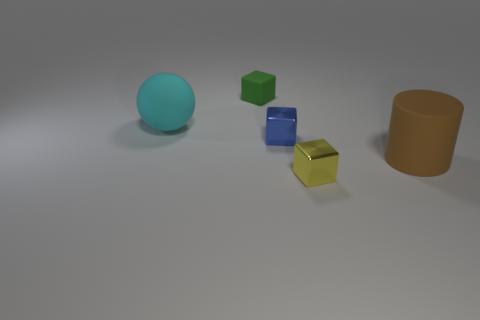Add 4 yellow metallic blocks. How many objects exist? 9 Subtract all small shiny cubes. How many cubes are left? 1 Subtract all green blocks. How many blocks are left? 2 Subtract 0 blue spheres. How many objects are left? 5 Subtract all spheres. How many objects are left? 4 Subtract 2 cubes. How many cubes are left? 1 Subtract all brown cubes. Subtract all gray balls. How many cubes are left? 3 Subtract all cyan cubes. How many gray spheres are left? 0 Subtract all blue shiny objects. Subtract all green objects. How many objects are left? 3 Add 4 cyan rubber things. How many cyan rubber things are left? 5 